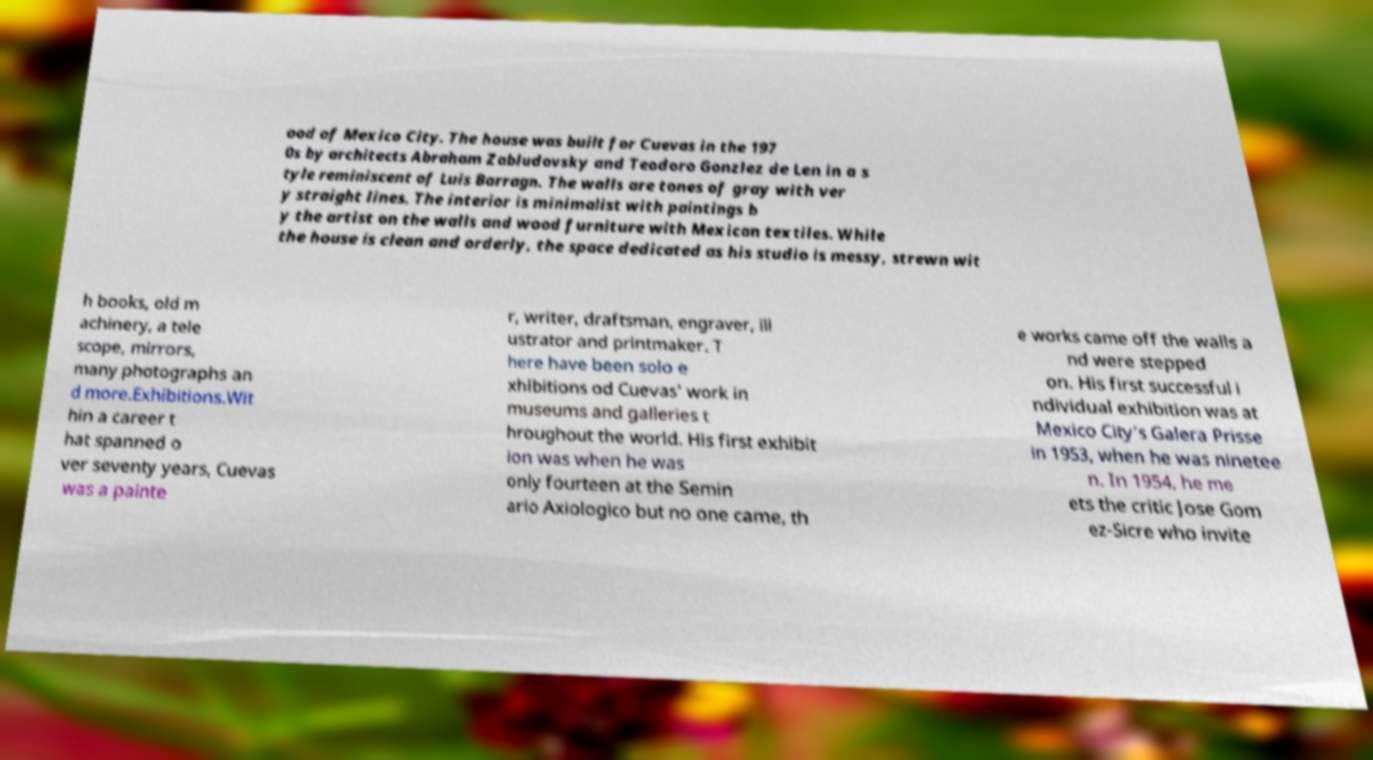What messages or text are displayed in this image? I need them in a readable, typed format. ood of Mexico City. The house was built for Cuevas in the 197 0s by architects Abraham Zabludovsky and Teodoro Gonzlez de Len in a s tyle reminiscent of Luis Barragn. The walls are tones of gray with ver y straight lines. The interior is minimalist with paintings b y the artist on the walls and wood furniture with Mexican textiles. While the house is clean and orderly, the space dedicated as his studio is messy, strewn wit h books, old m achinery, a tele scope, mirrors, many photographs an d more.Exhibitions.Wit hin a career t hat spanned o ver seventy years, Cuevas was a painte r, writer, draftsman, engraver, ill ustrator and printmaker. T here have been solo e xhibitions od Cuevas' work in museums and galleries t hroughout the world. His first exhibit ion was when he was only fourteen at the Semin ario Axiologico but no one came, th e works came off the walls a nd were stepped on. His first successful i ndividual exhibition was at Mexico City’s Galera Prisse in 1953, when he was ninetee n. In 1954, he me ets the critic Jose Gom ez-Sicre who invite 